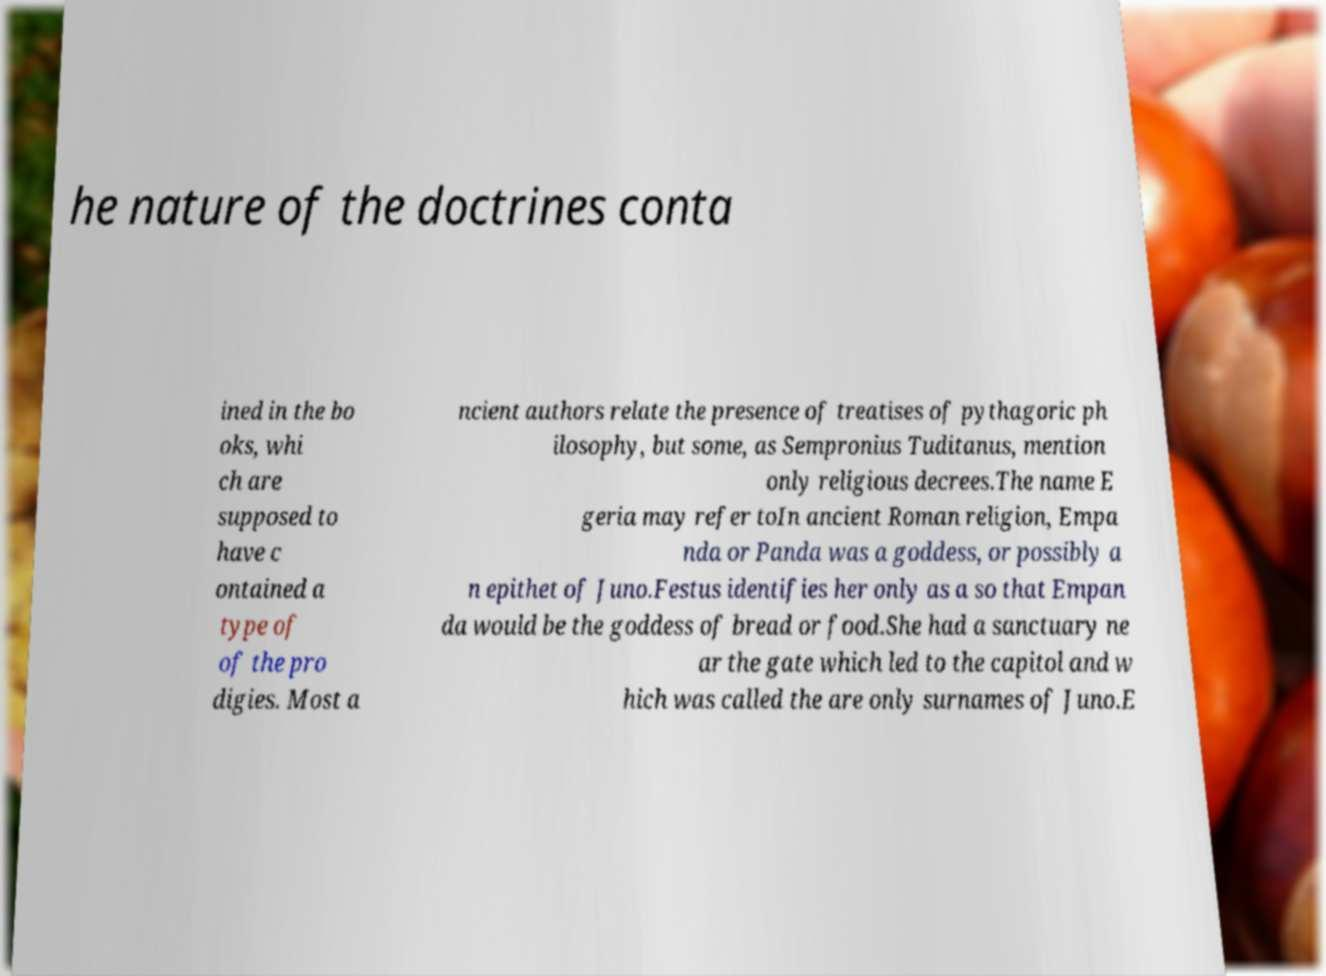There's text embedded in this image that I need extracted. Can you transcribe it verbatim? he nature of the doctrines conta ined in the bo oks, whi ch are supposed to have c ontained a type of of the pro digies. Most a ncient authors relate the presence of treatises of pythagoric ph ilosophy, but some, as Sempronius Tuditanus, mention only religious decrees.The name E geria may refer toIn ancient Roman religion, Empa nda or Panda was a goddess, or possibly a n epithet of Juno.Festus identifies her only as a so that Empan da would be the goddess of bread or food.She had a sanctuary ne ar the gate which led to the capitol and w hich was called the are only surnames of Juno.E 